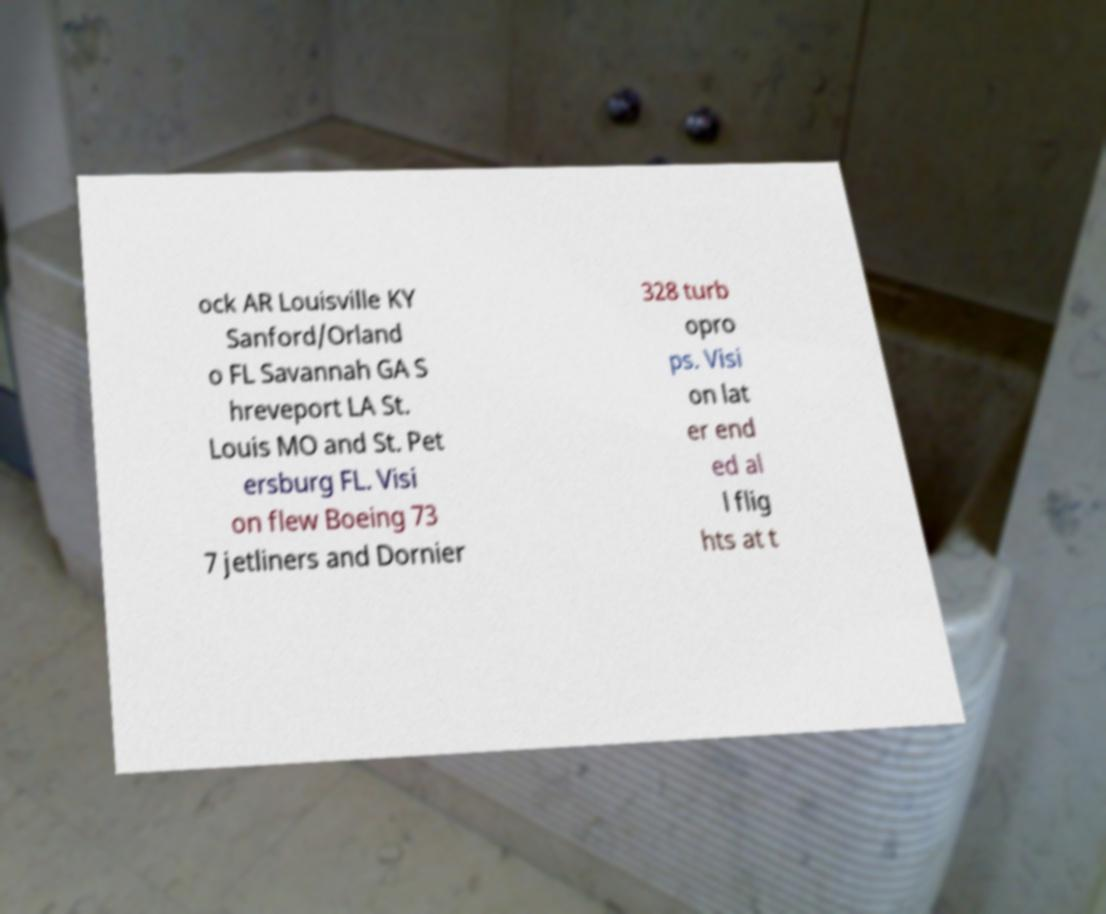Could you extract and type out the text from this image? ock AR Louisville KY Sanford/Orland o FL Savannah GA S hreveport LA St. Louis MO and St. Pet ersburg FL. Visi on flew Boeing 73 7 jetliners and Dornier 328 turb opro ps. Visi on lat er end ed al l flig hts at t 